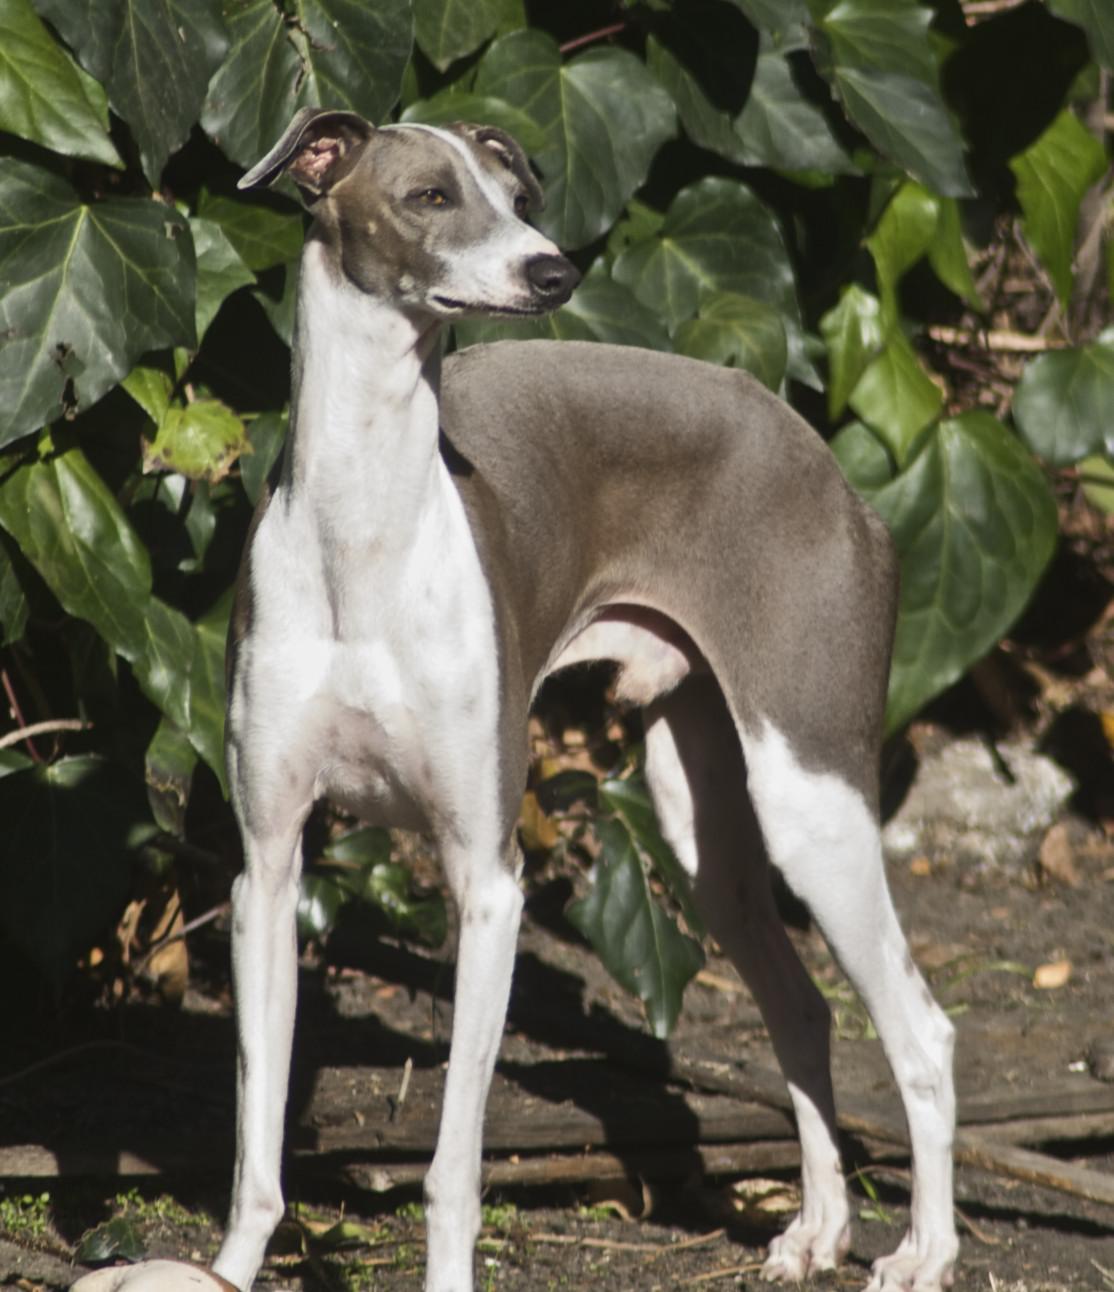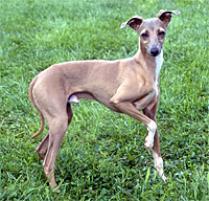The first image is the image on the left, the second image is the image on the right. Assess this claim about the two images: "The dog's legs are not visible in one of the images.". Correct or not? Answer yes or no. No. 